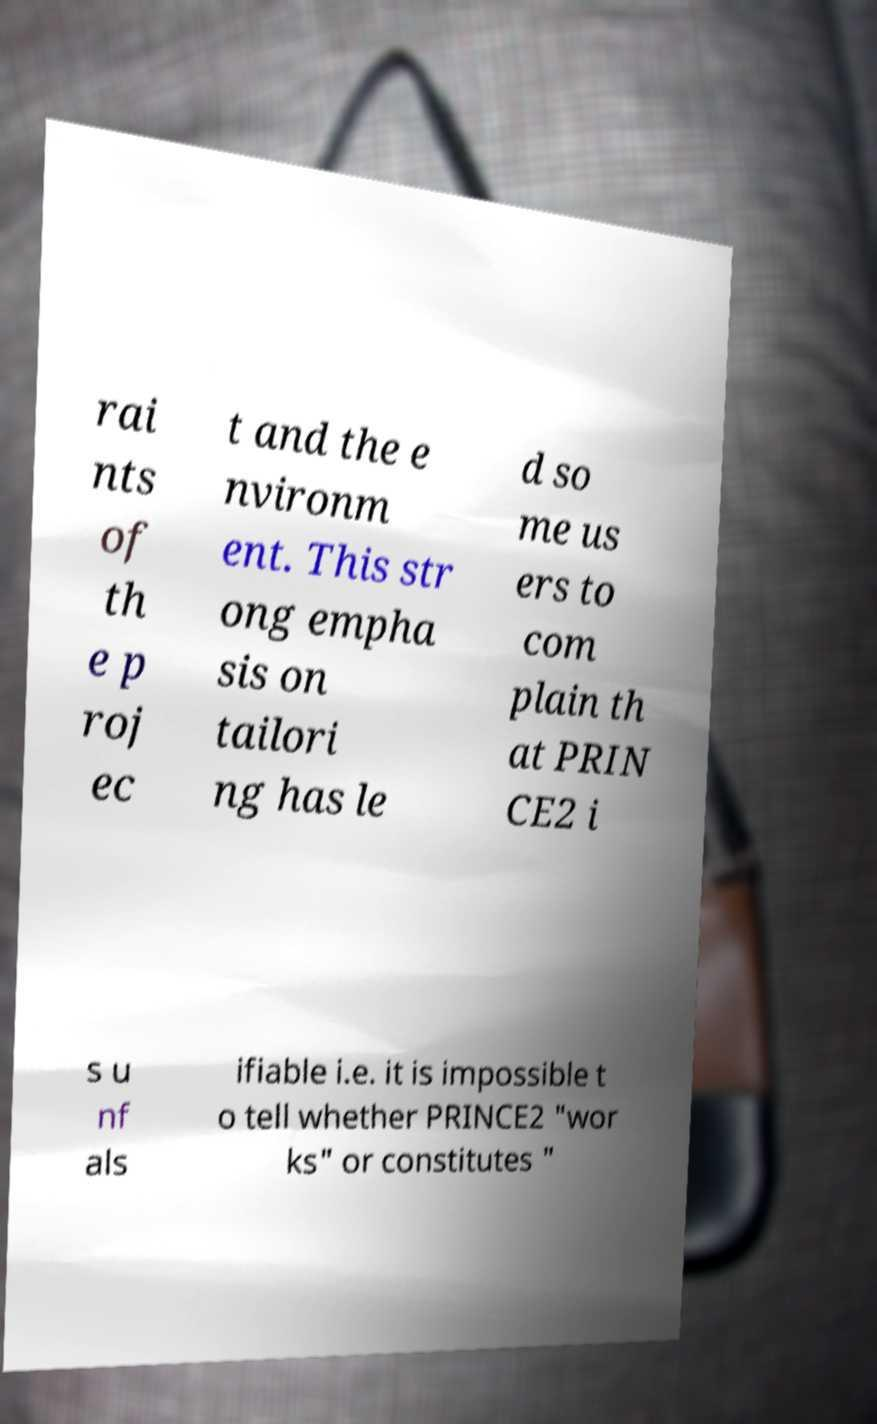Please read and relay the text visible in this image. What does it say? rai nts of th e p roj ec t and the e nvironm ent. This str ong empha sis on tailori ng has le d so me us ers to com plain th at PRIN CE2 i s u nf als ifiable i.e. it is impossible t o tell whether PRINCE2 "wor ks" or constitutes " 